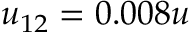<formula> <loc_0><loc_0><loc_500><loc_500>u _ { 1 2 } = 0 . 0 0 8 u</formula> 